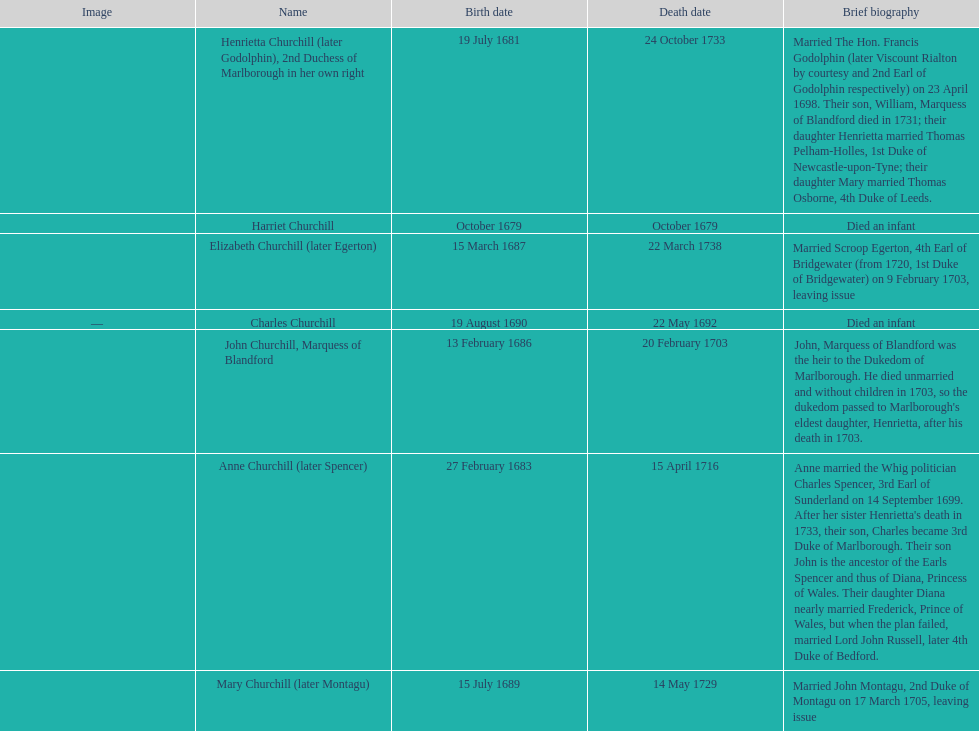How long did anne churchill/spencer live? 33. 